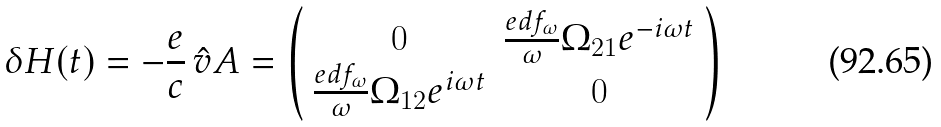Convert formula to latex. <formula><loc_0><loc_0><loc_500><loc_500>\delta H ( t ) = - \frac { e } { c } \, \hat { v } A = \left ( \begin{array} { c c c } 0 & \frac { e d f _ { \omega } } { \omega } \Omega _ { 2 1 } e ^ { - i \omega t } \\ \frac { e d f _ { \omega } } { \omega } \Omega _ { 1 2 } e ^ { i \omega t } & 0 \\ \end{array} \right )</formula> 